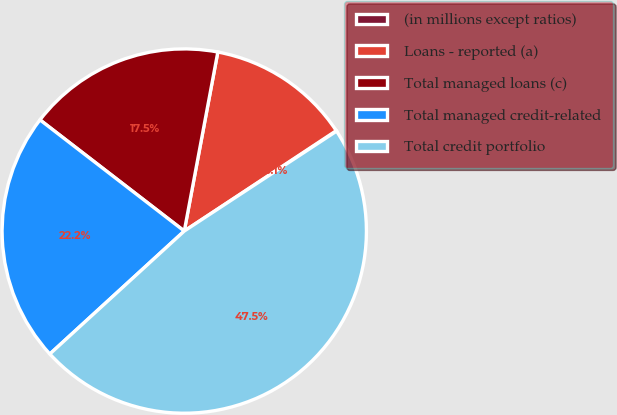<chart> <loc_0><loc_0><loc_500><loc_500><pie_chart><fcel>(in millions except ratios)<fcel>Loans - reported (a)<fcel>Total managed loans (c)<fcel>Total managed credit-related<fcel>Total credit portfolio<nl><fcel>0.05%<fcel>12.76%<fcel>17.5%<fcel>22.24%<fcel>47.45%<nl></chart> 